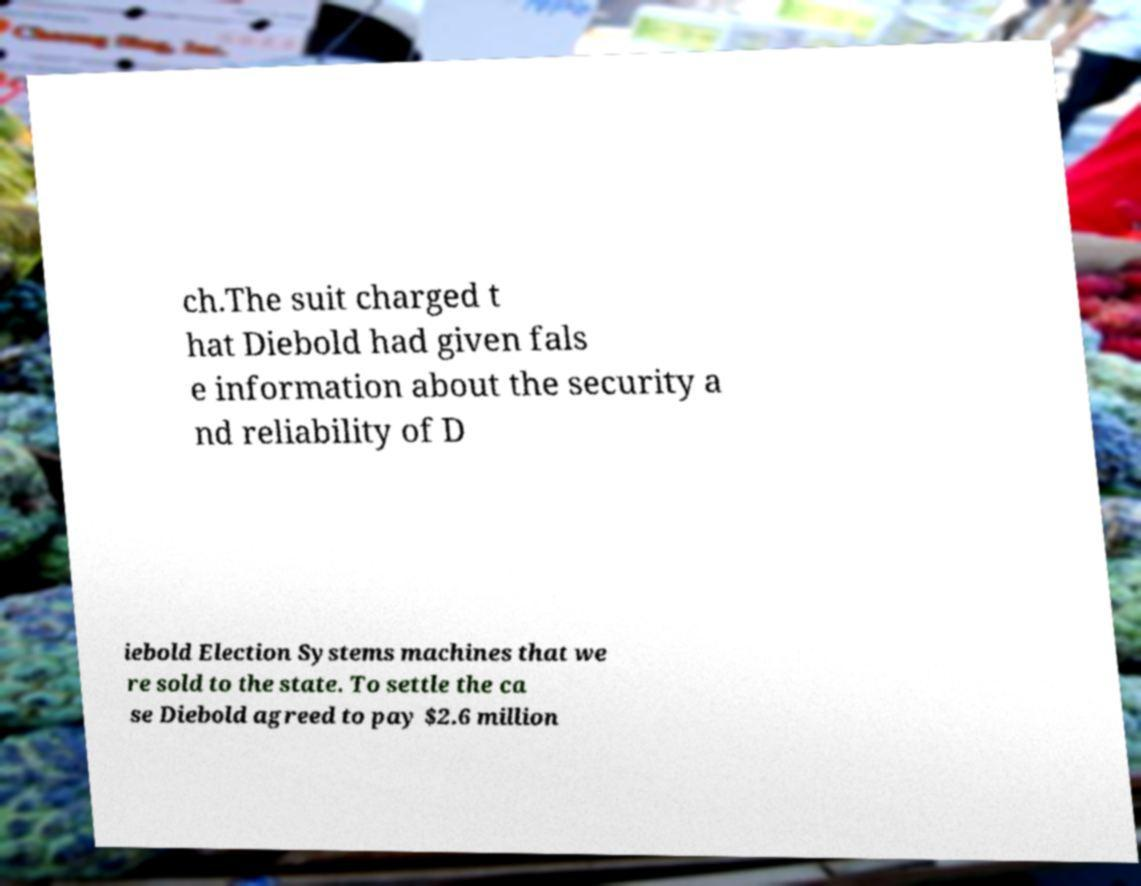What messages or text are displayed in this image? I need them in a readable, typed format. ch.The suit charged t hat Diebold had given fals e information about the security a nd reliability of D iebold Election Systems machines that we re sold to the state. To settle the ca se Diebold agreed to pay $2.6 million 